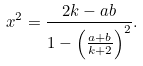<formula> <loc_0><loc_0><loc_500><loc_500>x ^ { 2 } = \frac { 2 k - a b } { 1 - \left ( \frac { a + b } { k + 2 } \right ) ^ { 2 } } .</formula> 